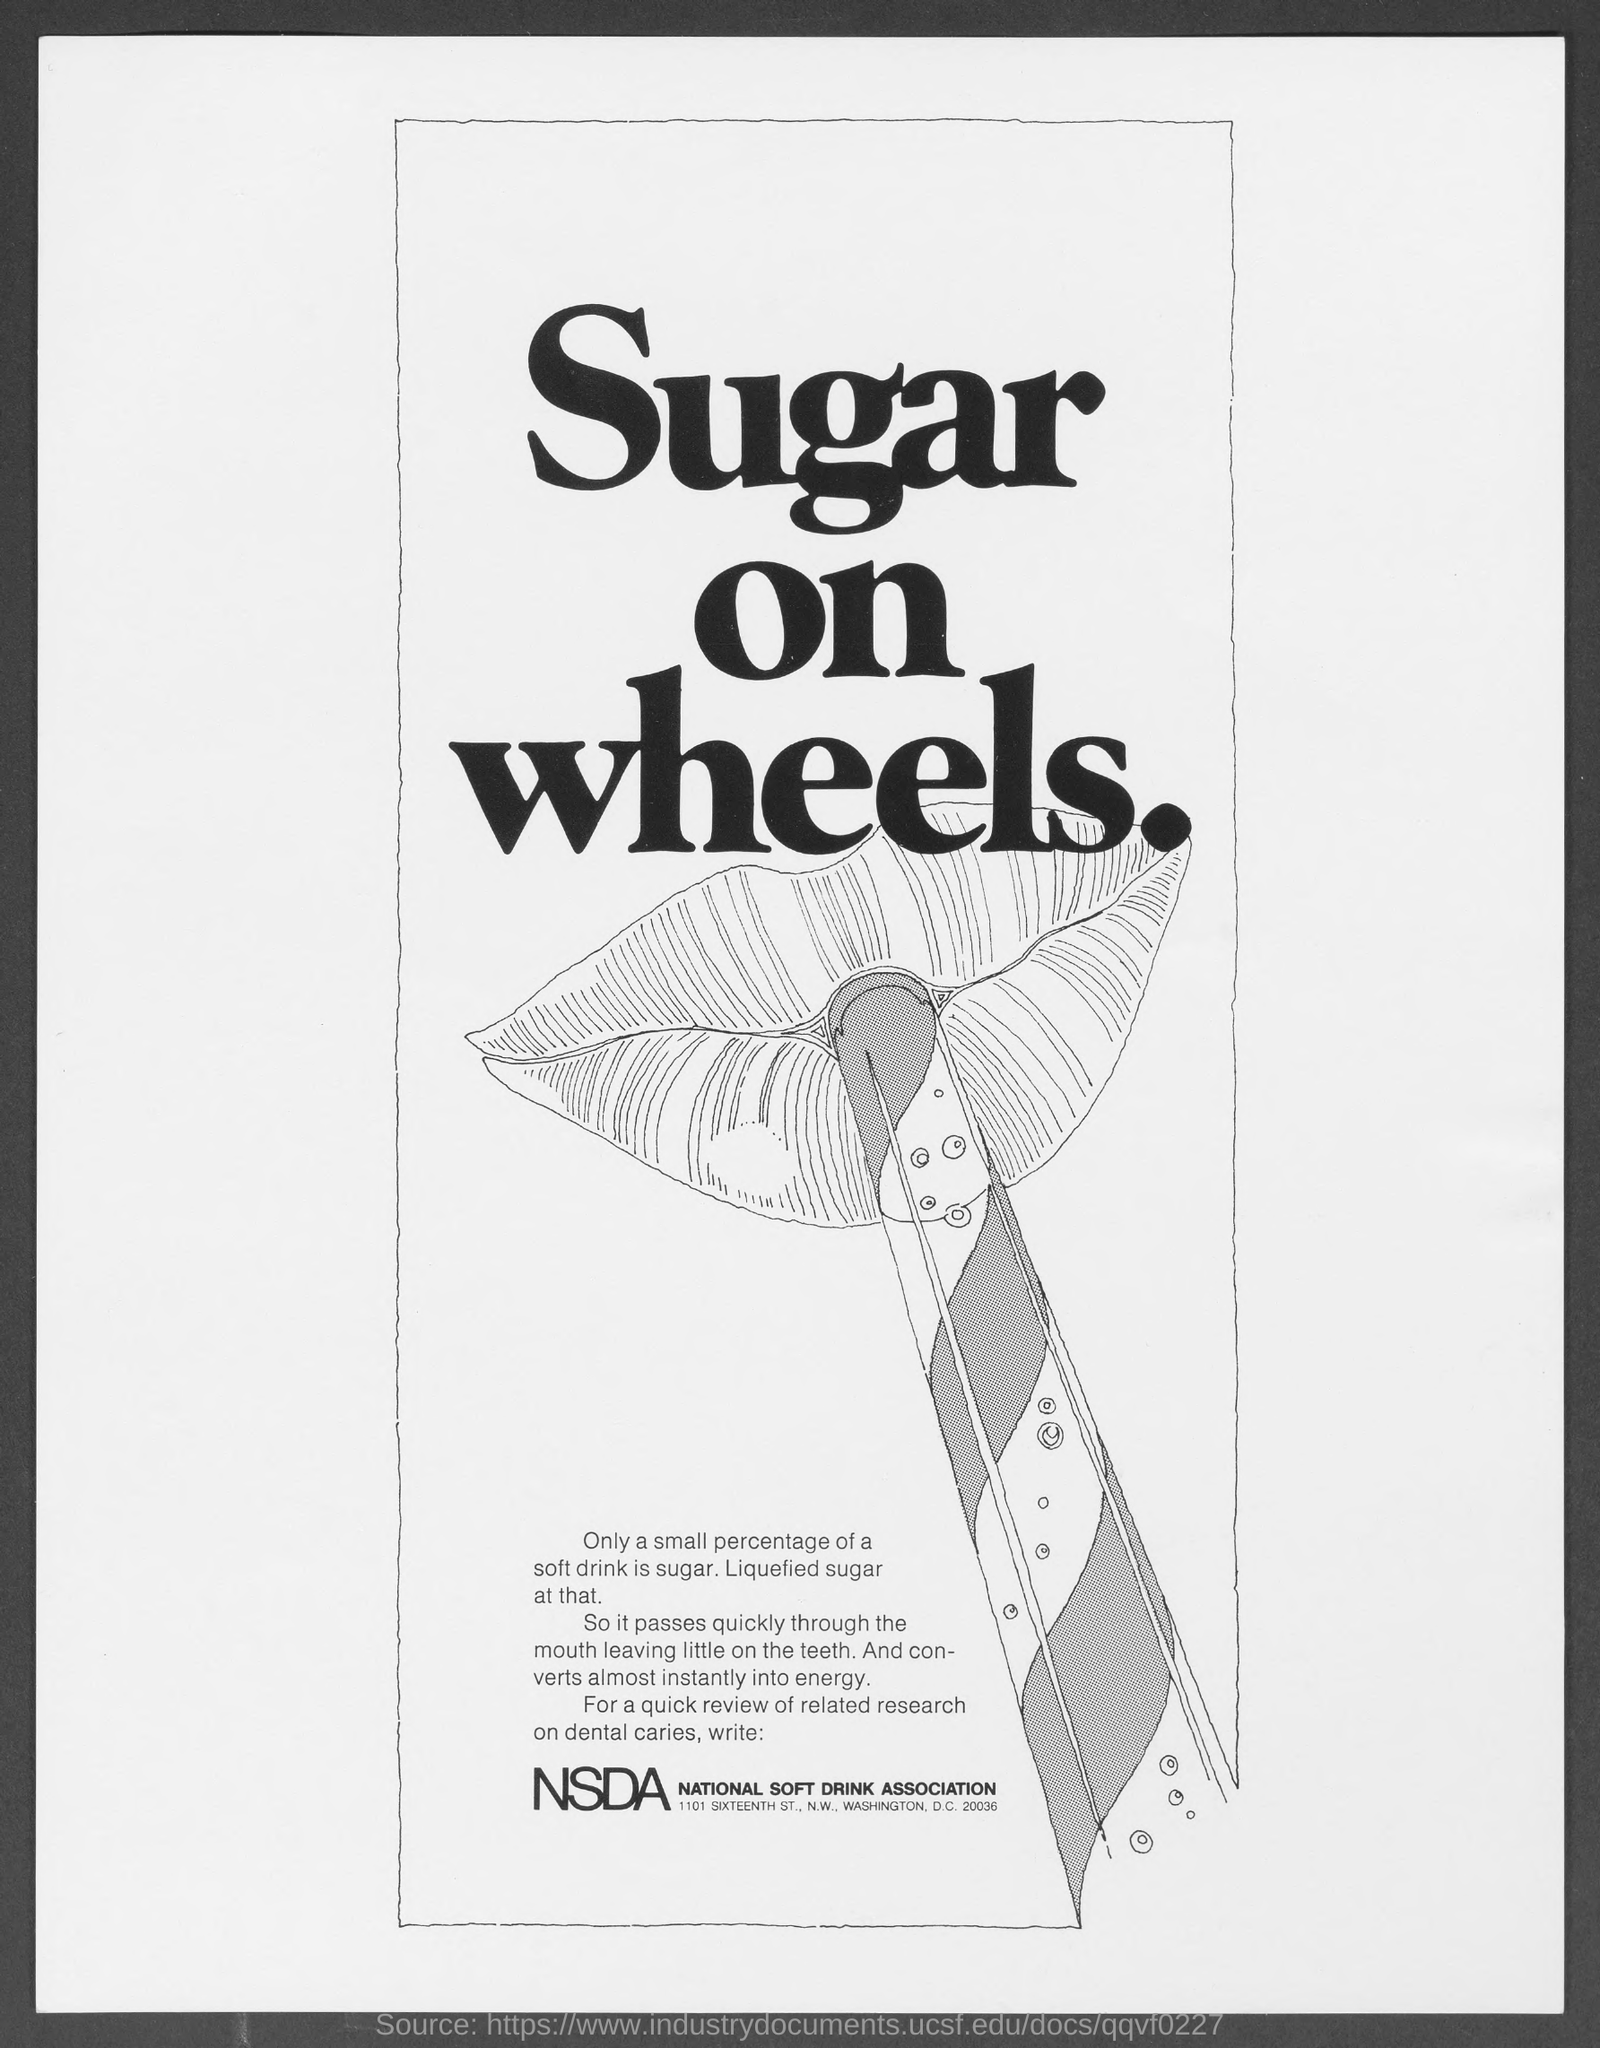What is the fullform of NSDA?
Your response must be concise. National Soft Drink Association. 